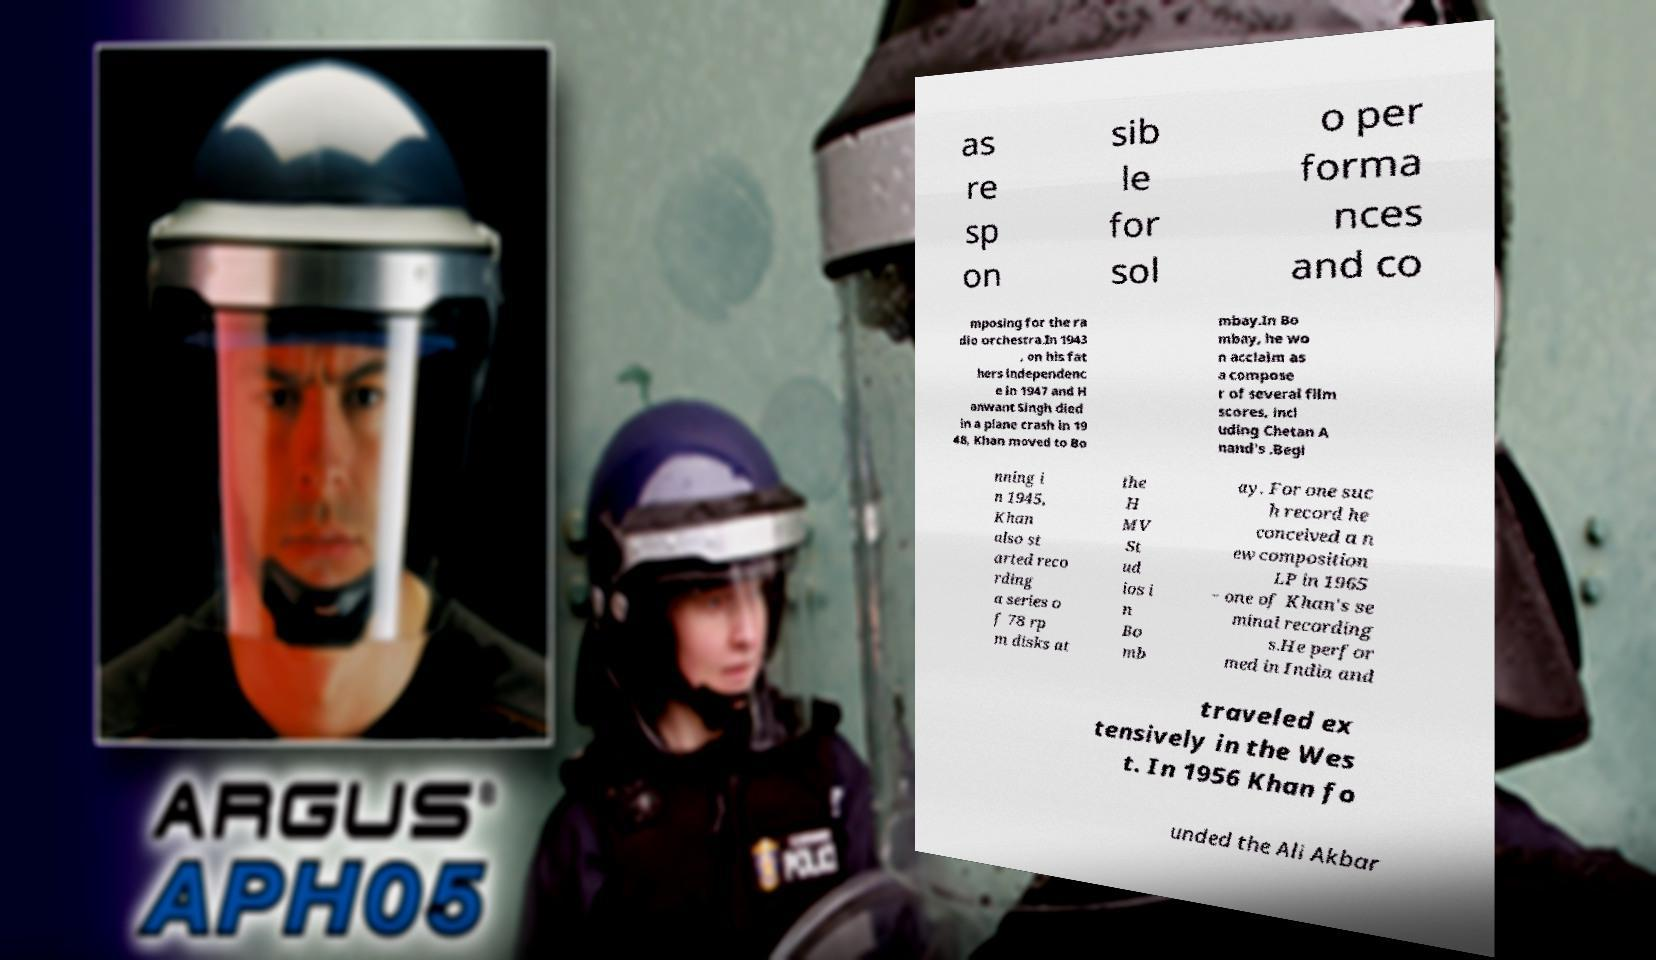I need the written content from this picture converted into text. Can you do that? as re sp on sib le for sol o per forma nces and co mposing for the ra dio orchestra.In 1943 , on his fat hers independenc e in 1947 and H anwant Singh died in a plane crash in 19 48, Khan moved to Bo mbay.In Bo mbay, he wo n acclaim as a compose r of several film scores, incl uding Chetan A nand's .Begi nning i n 1945, Khan also st arted reco rding a series o f 78 rp m disks at the H MV St ud ios i n Bo mb ay. For one suc h record he conceived a n ew composition LP in 1965 − one of Khan's se minal recording s.He perfor med in India and traveled ex tensively in the Wes t. In 1956 Khan fo unded the Ali Akbar 